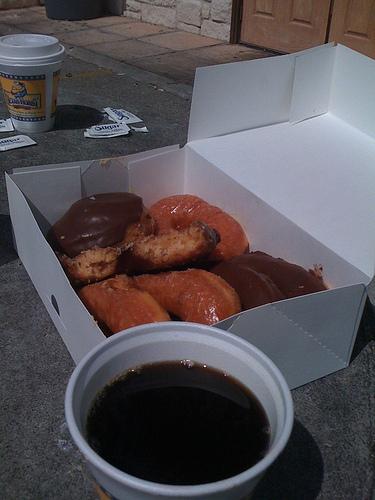What is beside the box?
Be succinct. Coffee. Will the customer need the knife for this meal?
Write a very short answer. No. What is in the box?
Quick response, please. Donuts. What color is the box?
Answer briefly. White. 